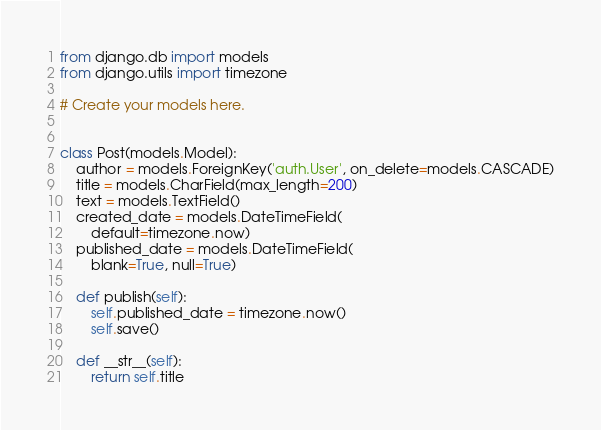<code> <loc_0><loc_0><loc_500><loc_500><_Python_>from django.db import models
from django.utils import timezone

# Create your models here.


class Post(models.Model):
    author = models.ForeignKey('auth.User', on_delete=models.CASCADE)
    title = models.CharField(max_length=200)
    text = models.TextField()
    created_date = models.DateTimeField(
        default=timezone.now)
    published_date = models.DateTimeField(
        blank=True, null=True)

    def publish(self):
        self.published_date = timezone.now()
        self.save()

    def __str__(self):
        return self.title
</code> 